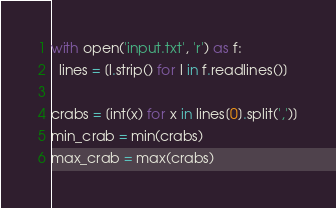<code> <loc_0><loc_0><loc_500><loc_500><_Python_>with open('input.txt', 'r') as f:
  lines = [l.strip() for l in f.readlines()]

crabs = [int(x) for x in lines[0].split(',')]
min_crab = min(crabs)
max_crab = max(crabs)</code> 